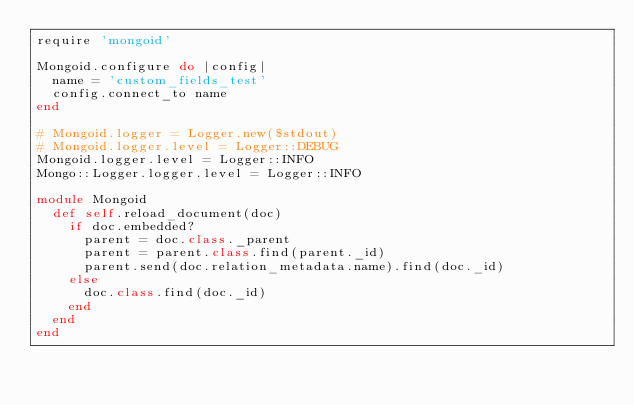<code> <loc_0><loc_0><loc_500><loc_500><_Ruby_>require 'mongoid'

Mongoid.configure do |config|
  name = 'custom_fields_test'
  config.connect_to name
end

# Mongoid.logger = Logger.new($stdout)
# Mongoid.logger.level = Logger::DEBUG
Mongoid.logger.level = Logger::INFO
Mongo::Logger.logger.level = Logger::INFO

module Mongoid
  def self.reload_document(doc)
    if doc.embedded?
      parent = doc.class._parent
      parent = parent.class.find(parent._id)
      parent.send(doc.relation_metadata.name).find(doc._id)
    else
      doc.class.find(doc._id)
    end
  end
end
</code> 